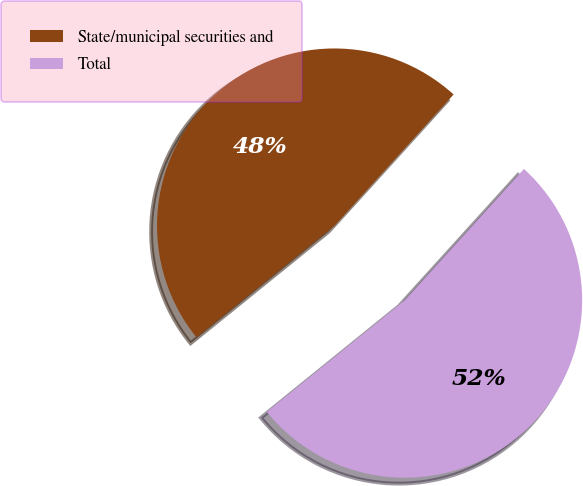Convert chart to OTSL. <chart><loc_0><loc_0><loc_500><loc_500><pie_chart><fcel>State/municipal securities and<fcel>Total<nl><fcel>47.55%<fcel>52.45%<nl></chart> 